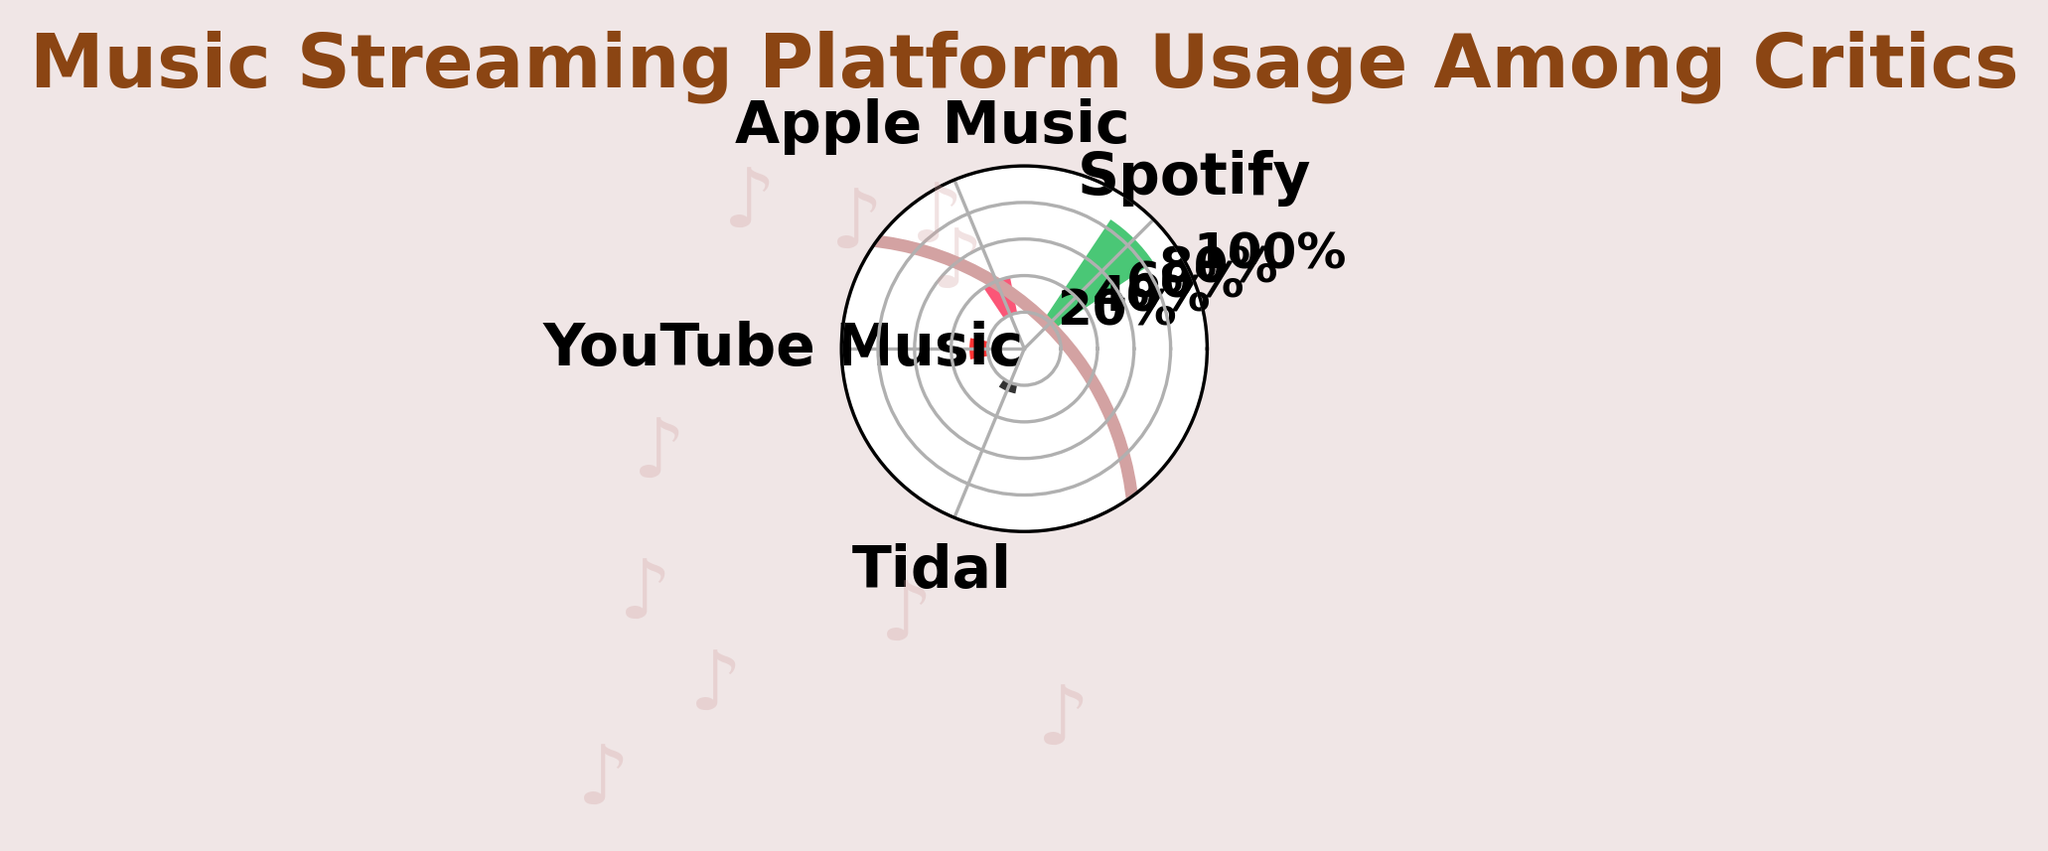Which streaming platform has the highest usage percentage among critics? The gauge chart shows four streaming platforms with different percentages, the highest percentage among them being 65% for Spotify.
Answer: Spotify What is the title of the figure? The title is displayed prominently at the top of the figure. It reads "Music Streaming Platform Usage Among Critics".
Answer: Music Streaming Platform Usage Among Critics What are the usage percentages for Apple Music and Tidal combined? Apple Music's usage percentage is 20% and Tidal's is 5%. Summing them up gives 20% + 5% = 25%.
Answer: 25% How does YouTube Music's usage percentage compare to Apple Music's? The chart shows YouTube Music's percentage as 10% and Apple Music's as 20%. Since 10% is less than 20%, YouTube Music's usage is lower.
Answer: Less Which platform has the lowest usage percentage and what is that percentage? Among Spotify, Apple Music, YouTube Music, and Tidal, Tidal has the lowest usage percentage, which is 5%.
Answer: Tidal, 5% What is the range of usage percentages shown in the figure? The minimum usage percentage shown is 5% (Tidal) and the maximum is 65% (Spotify). The range can be calculated as 65% - 5% = 60%.
Answer: 60% If another platform had 15% usage, where would it stand among the existing platforms in terms of percentage? Comparing 15% with the existing percentages: Spotify (65%), Apple Music (20%), YouTube Music (10%), and Tidal (5%), 15% would be between Apple Music and YouTube Music.
Answer: Between Apple Music and YouTube Music What is the combined percentage of Spotify and YouTube Music? The usage percentages for Spotify and YouTube Music are 65% and 10%, respectively. Adding them gives 65% + 10% = 75%.
Answer: 75% How many major streaming platforms are depicted in this gauge chart? The chart displays four platforms: Spotify, Apple Music, YouTube Music, and Tidal.
Answer: Four What color represents the Apple Music usage in the chart? Apple's distinctive color in the chart is pink. ∫ The background of the figure is light pink, indicating the use of pink hues, and Apple Music is shown with a color closest to pink.
Answer: Pink 